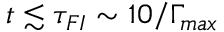Convert formula to latex. <formula><loc_0><loc_0><loc_500><loc_500>t \lesssim \tau _ { F I } \sim 1 0 / \Gamma _ { \max }</formula> 